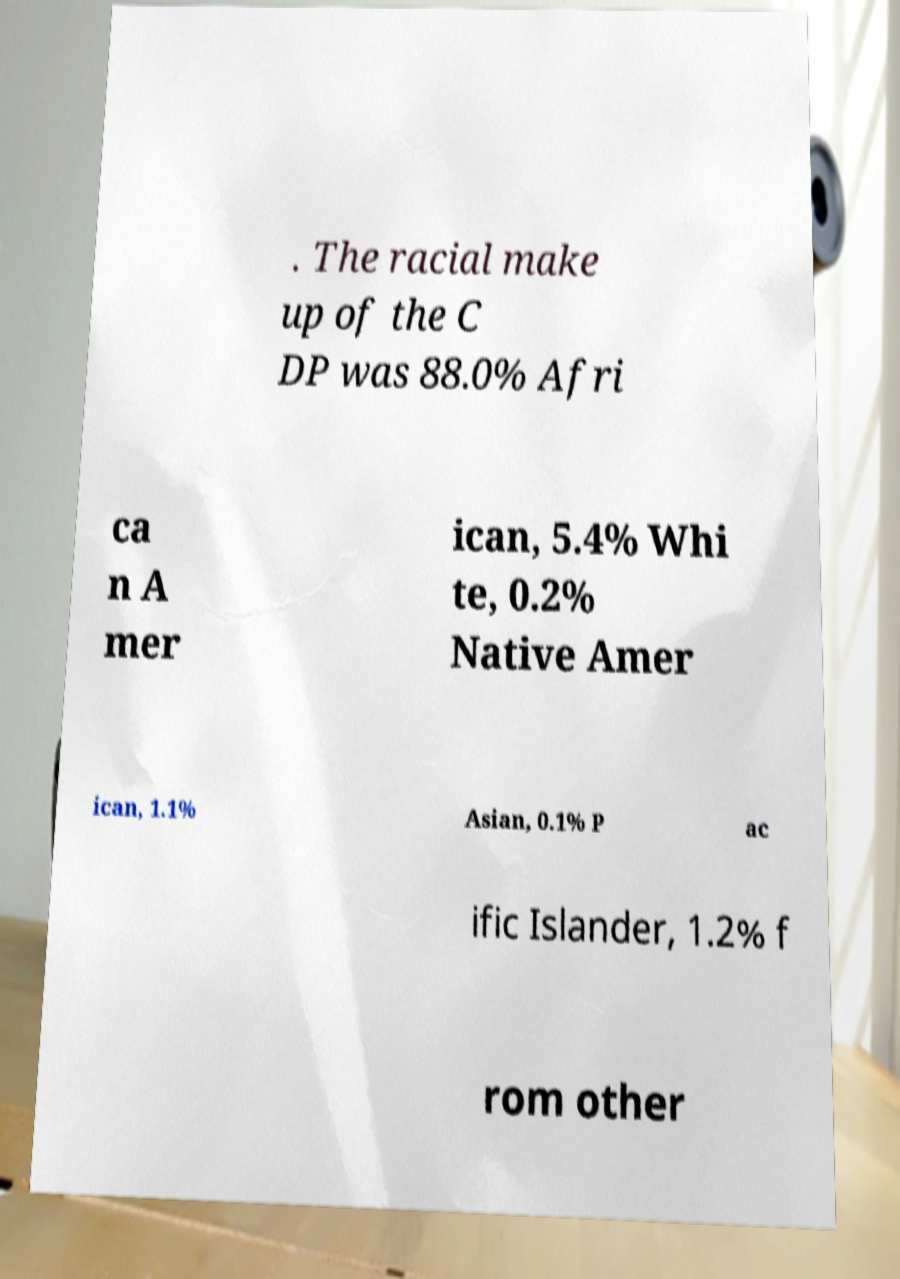Could you assist in decoding the text presented in this image and type it out clearly? . The racial make up of the C DP was 88.0% Afri ca n A mer ican, 5.4% Whi te, 0.2% Native Amer ican, 1.1% Asian, 0.1% P ac ific Islander, 1.2% f rom other 